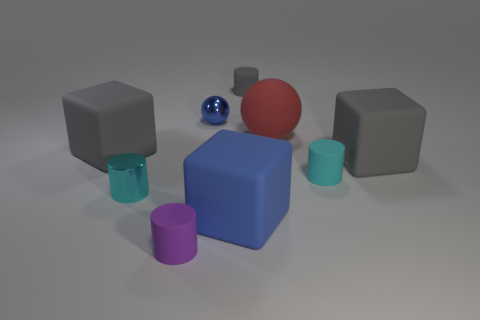Do the purple cylinder and the red object have the same material?
Offer a terse response. Yes. There is a cyan object in front of the cyan cylinder that is on the right side of the tiny cyan metallic cylinder; are there any gray matte cubes right of it?
Give a very brief answer. Yes. What number of other objects are the same shape as the tiny purple matte thing?
Your answer should be very brief. 3. The gray matte thing that is in front of the small gray cylinder and right of the tiny purple rubber cylinder has what shape?
Your answer should be very brief. Cube. What color is the ball that is to the right of the tiny cylinder that is behind the cyan cylinder that is to the right of the blue rubber cube?
Provide a succinct answer. Red. Are there more large gray objects that are in front of the tiny cyan matte thing than small metallic cylinders to the left of the large rubber ball?
Provide a short and direct response. No. How many other things are there of the same size as the purple rubber cylinder?
Make the answer very short. 4. There is a matte cylinder that is the same color as the shiny cylinder; what size is it?
Provide a succinct answer. Small. What material is the cylinder behind the big gray matte thing that is left of the matte sphere made of?
Keep it short and to the point. Rubber. Are there any large blue things to the left of the tiny purple rubber cylinder?
Your response must be concise. No. 